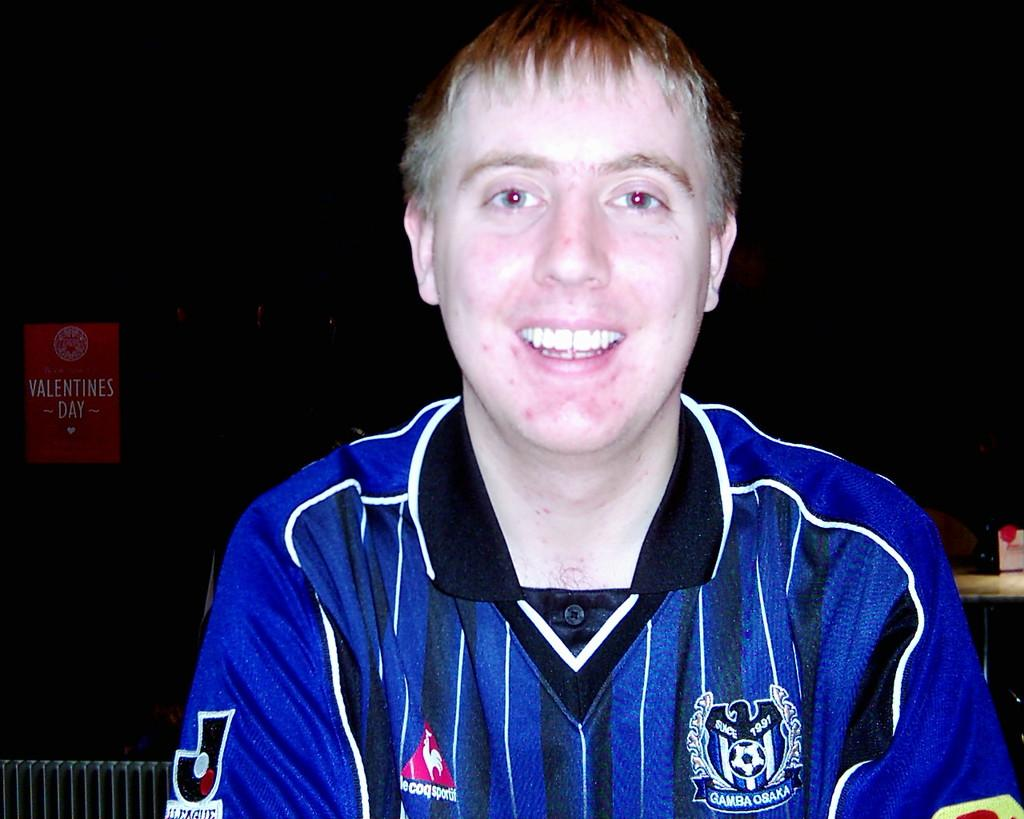What is the person in the image doing? The person is sitting in the image. What is the facial expression of the person? The person is smiling. What color is the jersey worn by the person? The person is wearing a blue color jersey. How would you describe the background of the image? The backdrop of the image is dark. What can be seen on the left side of the image? There is a red color poster on the left side of the image. What type of hill can be seen in the background of the image? There is no hill visible in the background of the image; the backdrop is dark. 